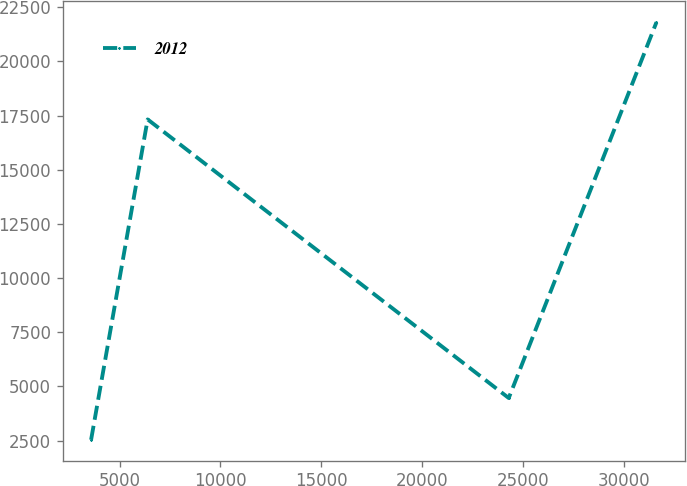Convert chart to OTSL. <chart><loc_0><loc_0><loc_500><loc_500><line_chart><ecel><fcel>2012<nl><fcel>3588.66<fcel>2538.76<nl><fcel>6392.3<fcel>17323.5<nl><fcel>24301.2<fcel>4465.23<nl><fcel>31625<fcel>21803.4<nl></chart> 